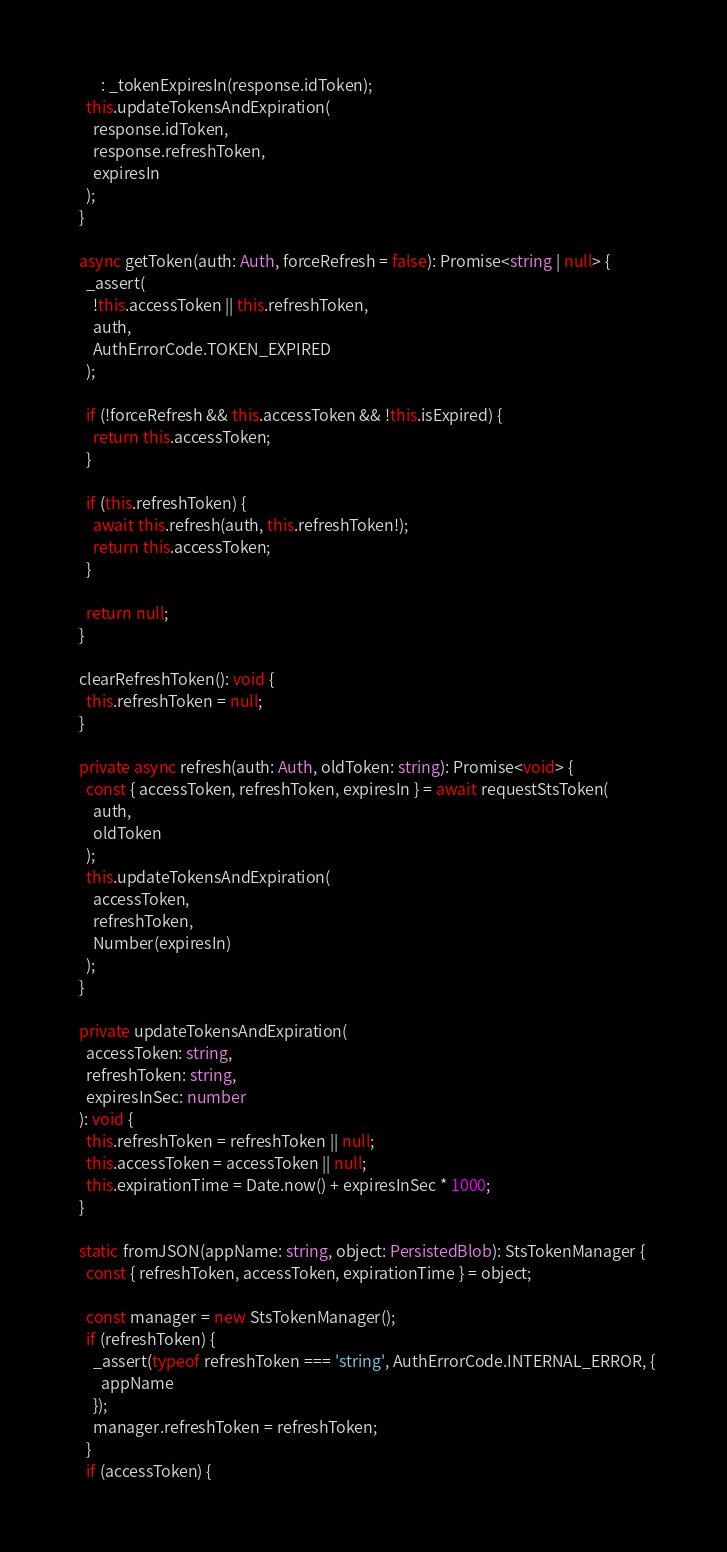<code> <loc_0><loc_0><loc_500><loc_500><_TypeScript_>        : _tokenExpiresIn(response.idToken);
    this.updateTokensAndExpiration(
      response.idToken,
      response.refreshToken,
      expiresIn
    );
  }

  async getToken(auth: Auth, forceRefresh = false): Promise<string | null> {
    _assert(
      !this.accessToken || this.refreshToken,
      auth,
      AuthErrorCode.TOKEN_EXPIRED
    );

    if (!forceRefresh && this.accessToken && !this.isExpired) {
      return this.accessToken;
    }

    if (this.refreshToken) {
      await this.refresh(auth, this.refreshToken!);
      return this.accessToken;
    }

    return null;
  }

  clearRefreshToken(): void {
    this.refreshToken = null;
  }

  private async refresh(auth: Auth, oldToken: string): Promise<void> {
    const { accessToken, refreshToken, expiresIn } = await requestStsToken(
      auth,
      oldToken
    );
    this.updateTokensAndExpiration(
      accessToken,
      refreshToken,
      Number(expiresIn)
    );
  }

  private updateTokensAndExpiration(
    accessToken: string,
    refreshToken: string,
    expiresInSec: number
  ): void {
    this.refreshToken = refreshToken || null;
    this.accessToken = accessToken || null;
    this.expirationTime = Date.now() + expiresInSec * 1000;
  }

  static fromJSON(appName: string, object: PersistedBlob): StsTokenManager {
    const { refreshToken, accessToken, expirationTime } = object;

    const manager = new StsTokenManager();
    if (refreshToken) {
      _assert(typeof refreshToken === 'string', AuthErrorCode.INTERNAL_ERROR, {
        appName
      });
      manager.refreshToken = refreshToken;
    }
    if (accessToken) {</code> 